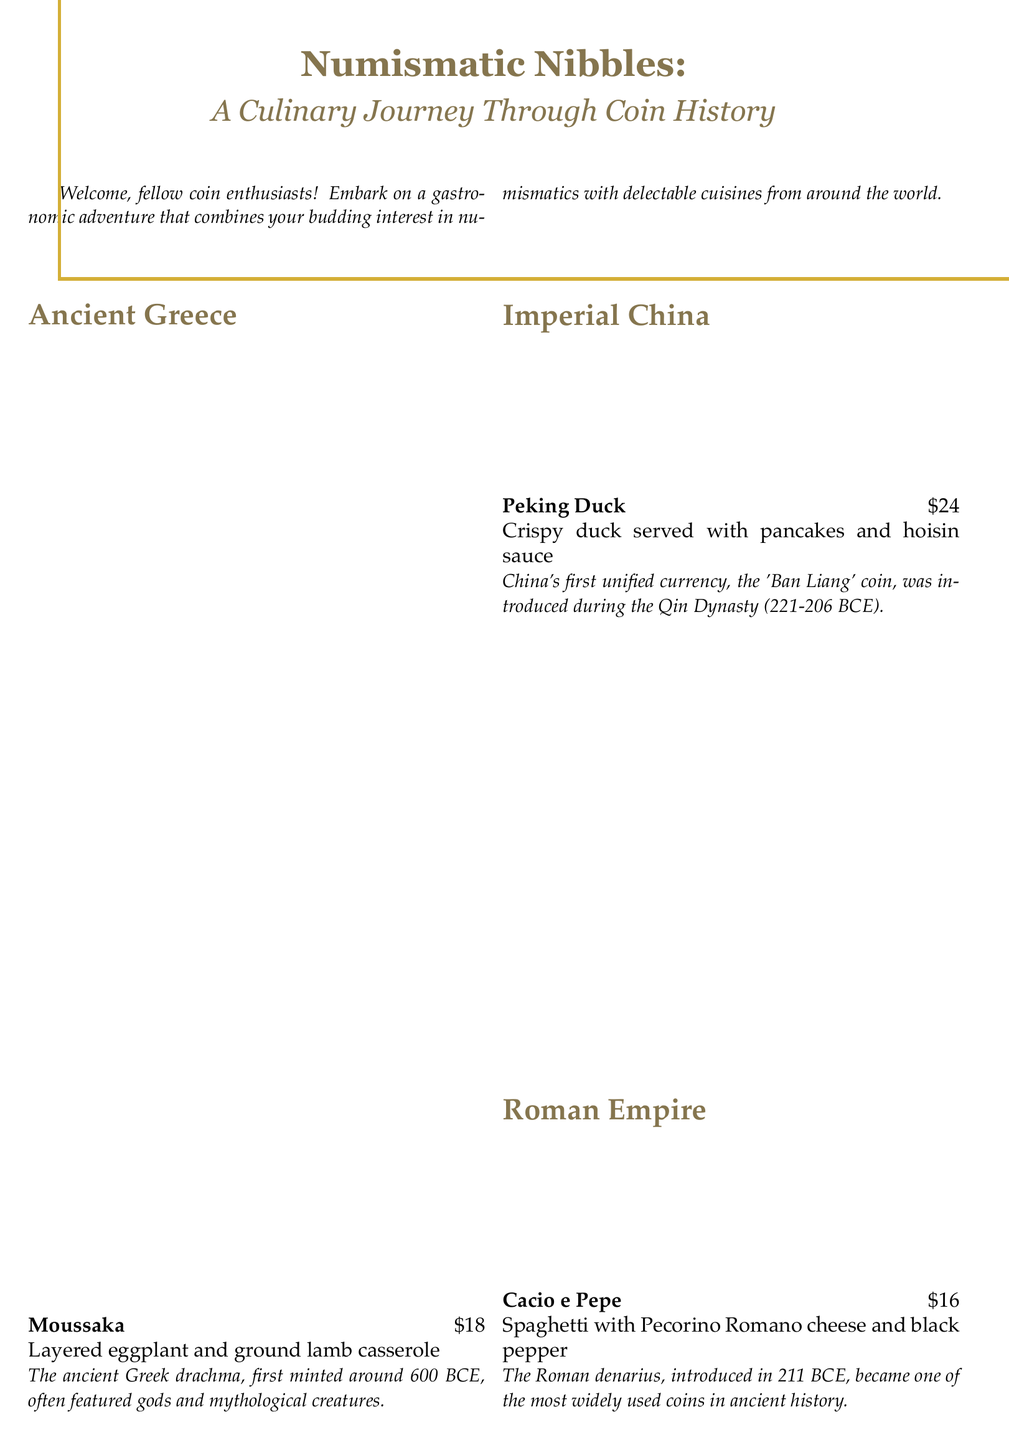What is the name of the dish from Ancient Greece? The menu lists "Moussaka" as the dish from Ancient Greece.
Answer: Moussaka How much does the Peking Duck cost? The cost of Peking Duck is specifically stated in the menu.
Answer: $24 What coin was introduced in Imperial China? The menu mentions the "Ban Liang" coin as the first unified currency in China.
Answer: Ban Liang Which dish features minced lamb? The menu indicates that "Shepherd's Pie" includes minced lamb.
Answer: Shepherd's Pie In what century was the silver penny introduced in England? The menu states it was introduced in the 8th century.
Answer: 8th century What historical period is associated with the Roman denarius? The Roman denarius was introduced in 211 BCE, indicating its historical period.
Answer: 211 BCE What is the main ingredient in Cacio e Pepe? The dish Cacio e Pepe is primarily made with Pecorino Romano cheese.
Answer: Pecorino Romano cheese How many cuisines are featured in the menu? The total count of cuisines listed on the menu, as seen, is four.
Answer: Four What type of collectible is offered with a meal purchase? The menu mentions a "commemorative restaurant token" as a gift with purchase.
Answer: Commemorative restaurant token 